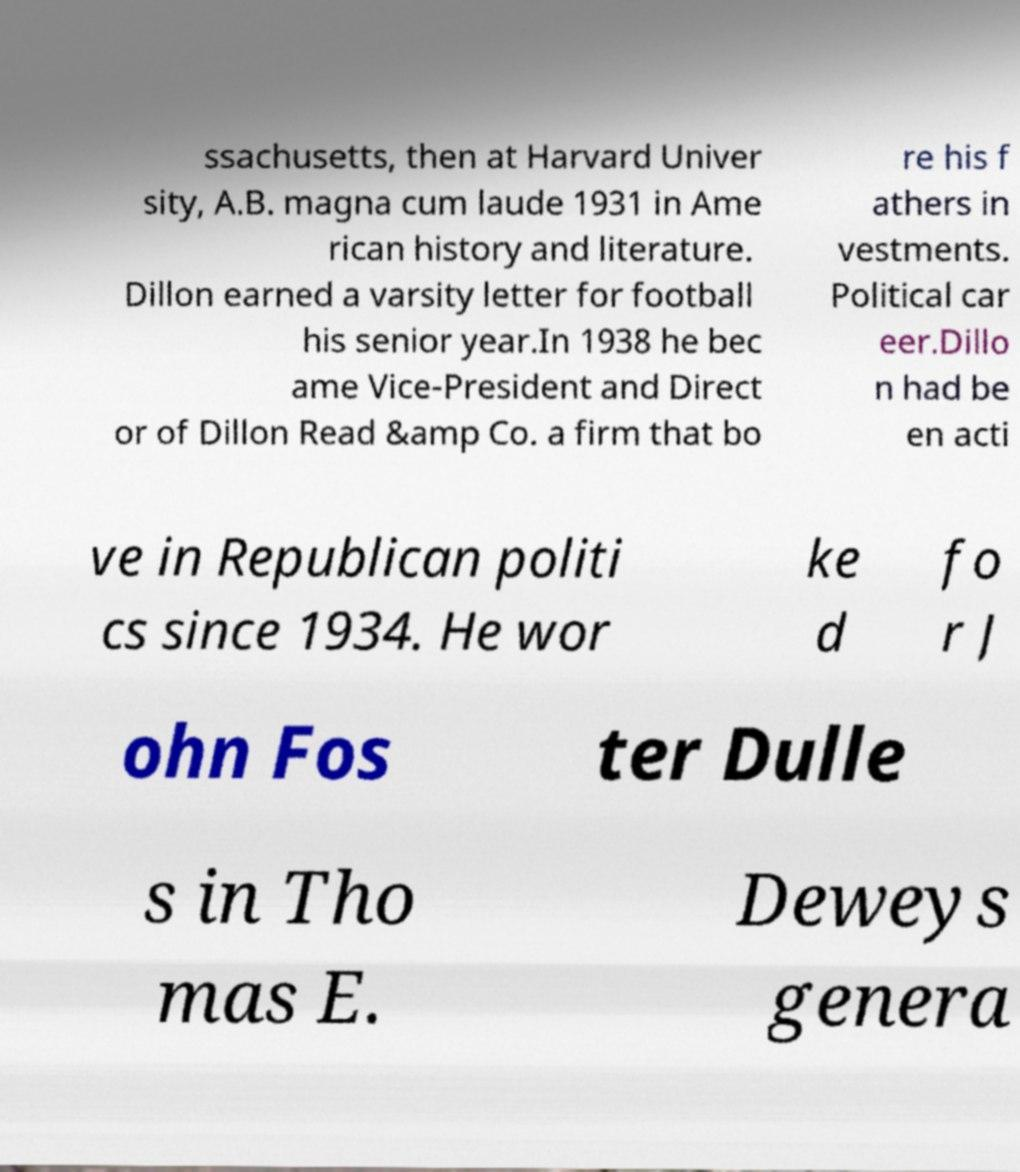Could you extract and type out the text from this image? ssachusetts, then at Harvard Univer sity, A.B. magna cum laude 1931 in Ame rican history and literature. Dillon earned a varsity letter for football his senior year.In 1938 he bec ame Vice-President and Direct or of Dillon Read &amp Co. a firm that bo re his f athers in vestments. Political car eer.Dillo n had be en acti ve in Republican politi cs since 1934. He wor ke d fo r J ohn Fos ter Dulle s in Tho mas E. Deweys genera 